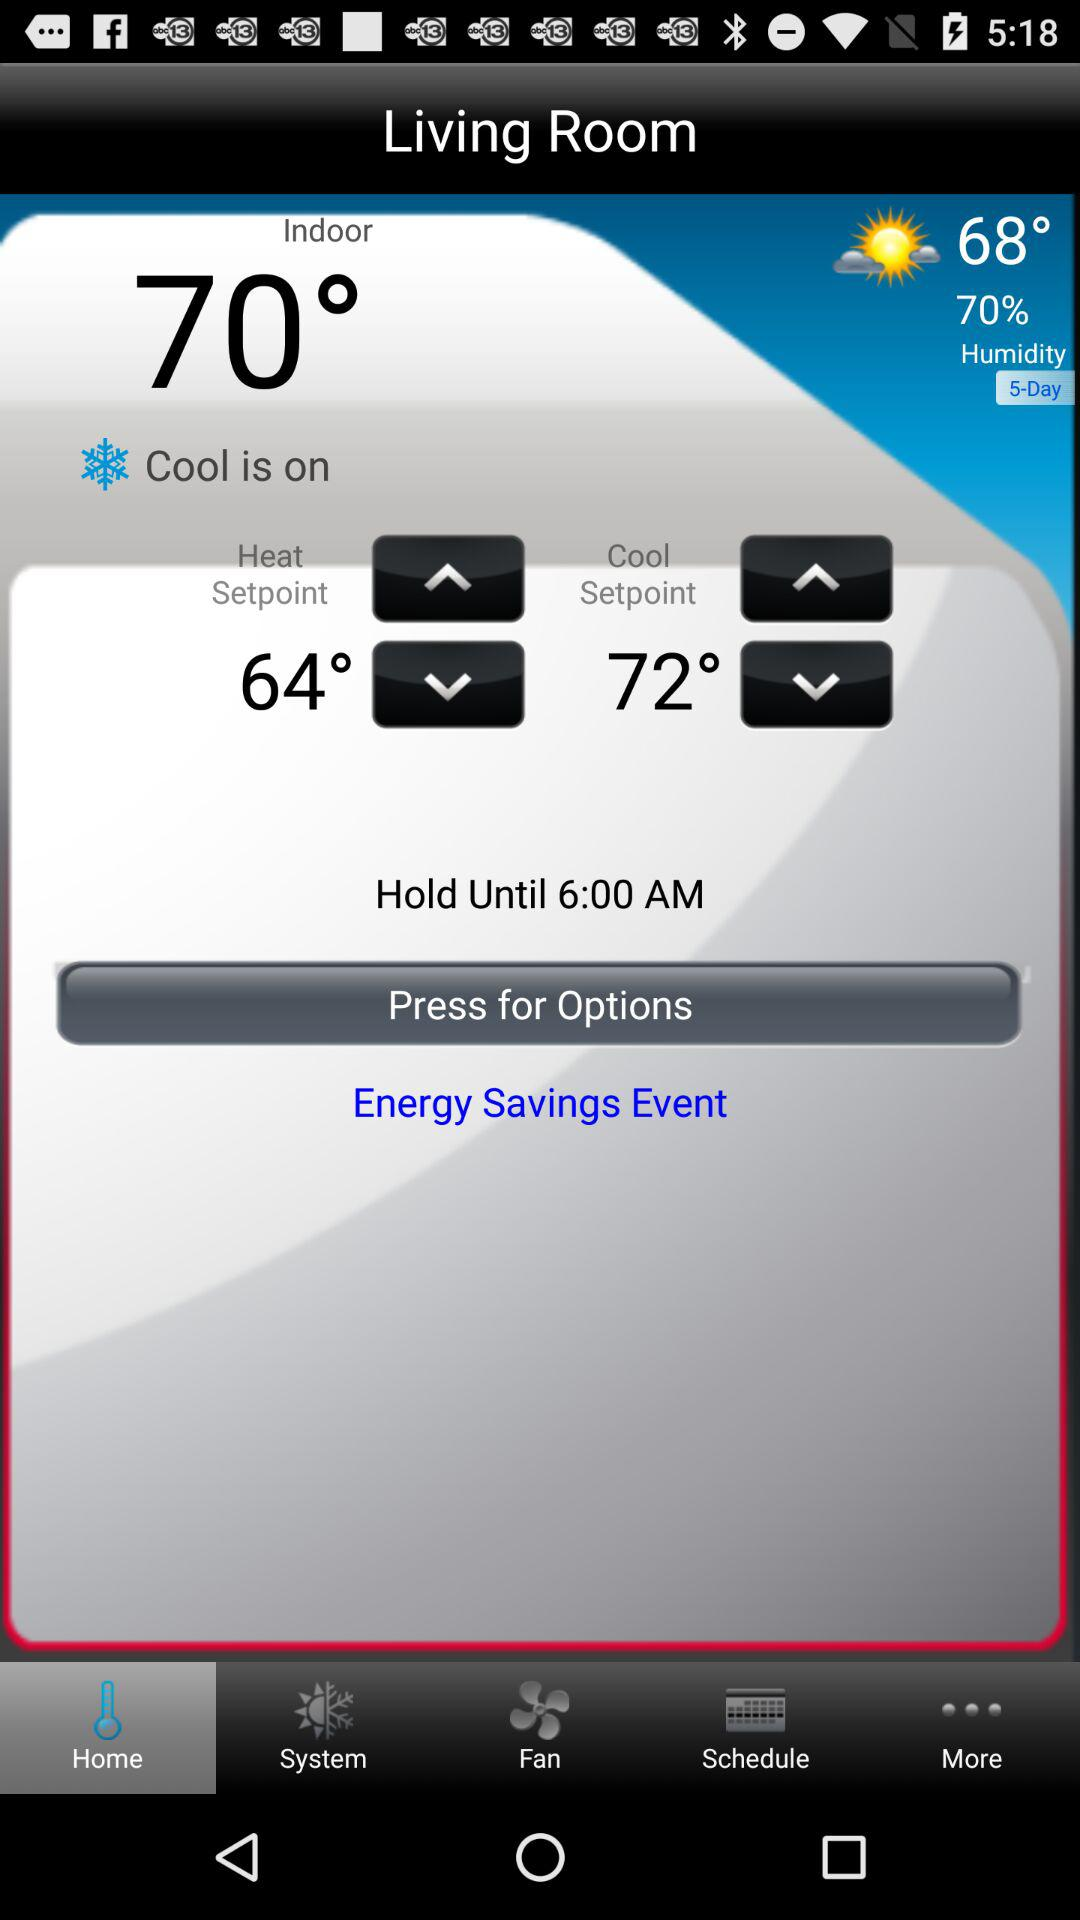How do you participate in the energy savings event?
When the provided information is insufficient, respond with <no answer>. <no answer> 